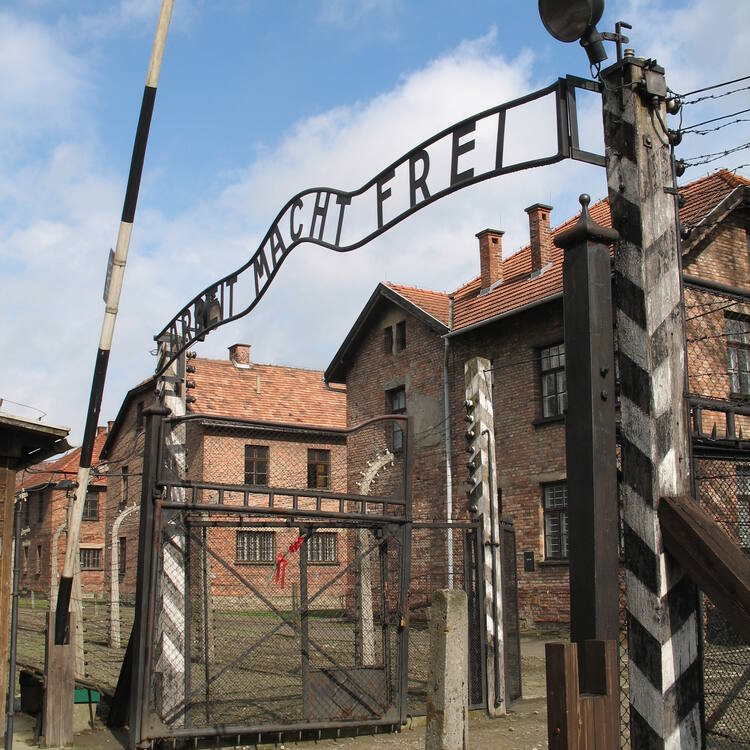What can visitors learn from visiting the Auschwitz site today? Visitors to Auschwitz today can learn about the profound and tragic history of the Holocaust. The preserved site offers a somber education on the extent of human cruelty and the consequences of unchecked hatred and bigotry. Walking through the barracks, seeing the remnants of personal belongings, and standing in the places where so many suffered, visitors can gain a deeper understanding of the scale of the atrocities committed. The experience underscores the importance of remembering the past to ensure that such horrors are never repeated. It also serves as a powerful reminder of the resilience of the human spirit and the importance of standing up against oppression and discrimination. 